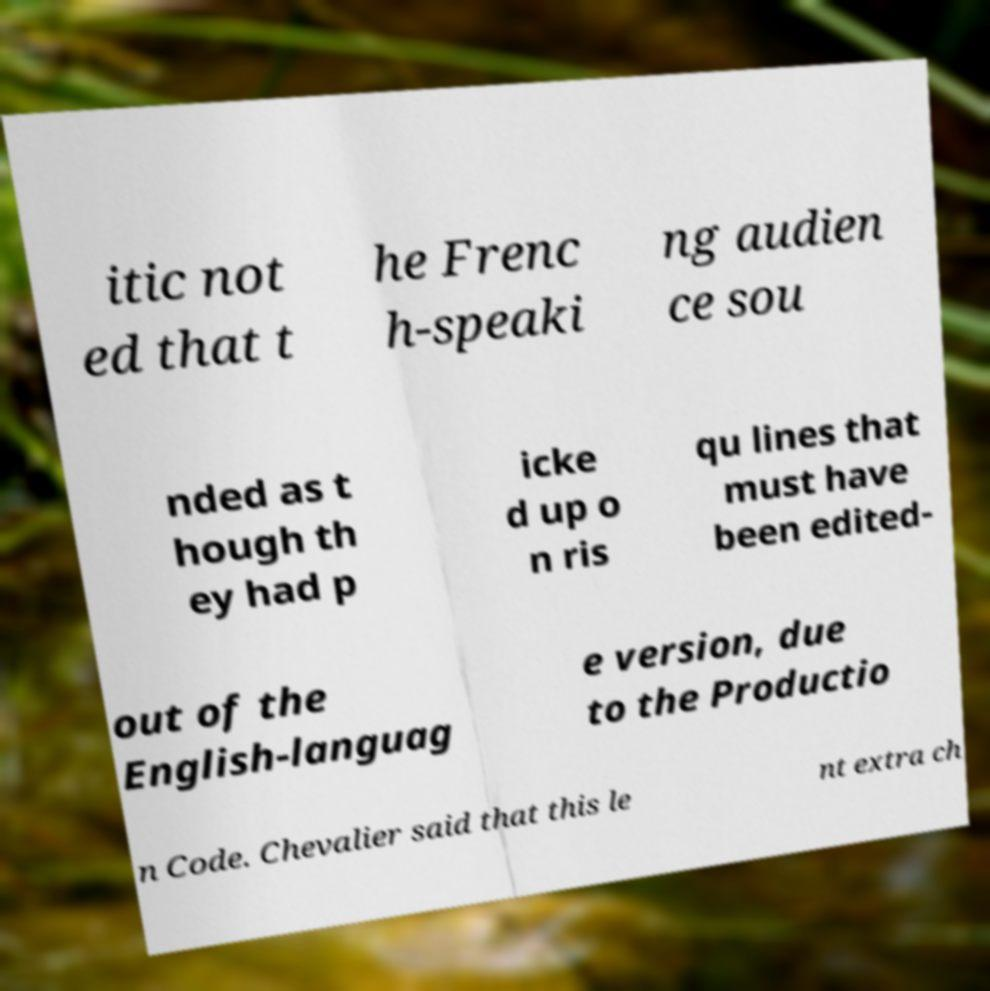Can you read and provide the text displayed in the image?This photo seems to have some interesting text. Can you extract and type it out for me? itic not ed that t he Frenc h-speaki ng audien ce sou nded as t hough th ey had p icke d up o n ris qu lines that must have been edited- out of the English-languag e version, due to the Productio n Code. Chevalier said that this le nt extra ch 